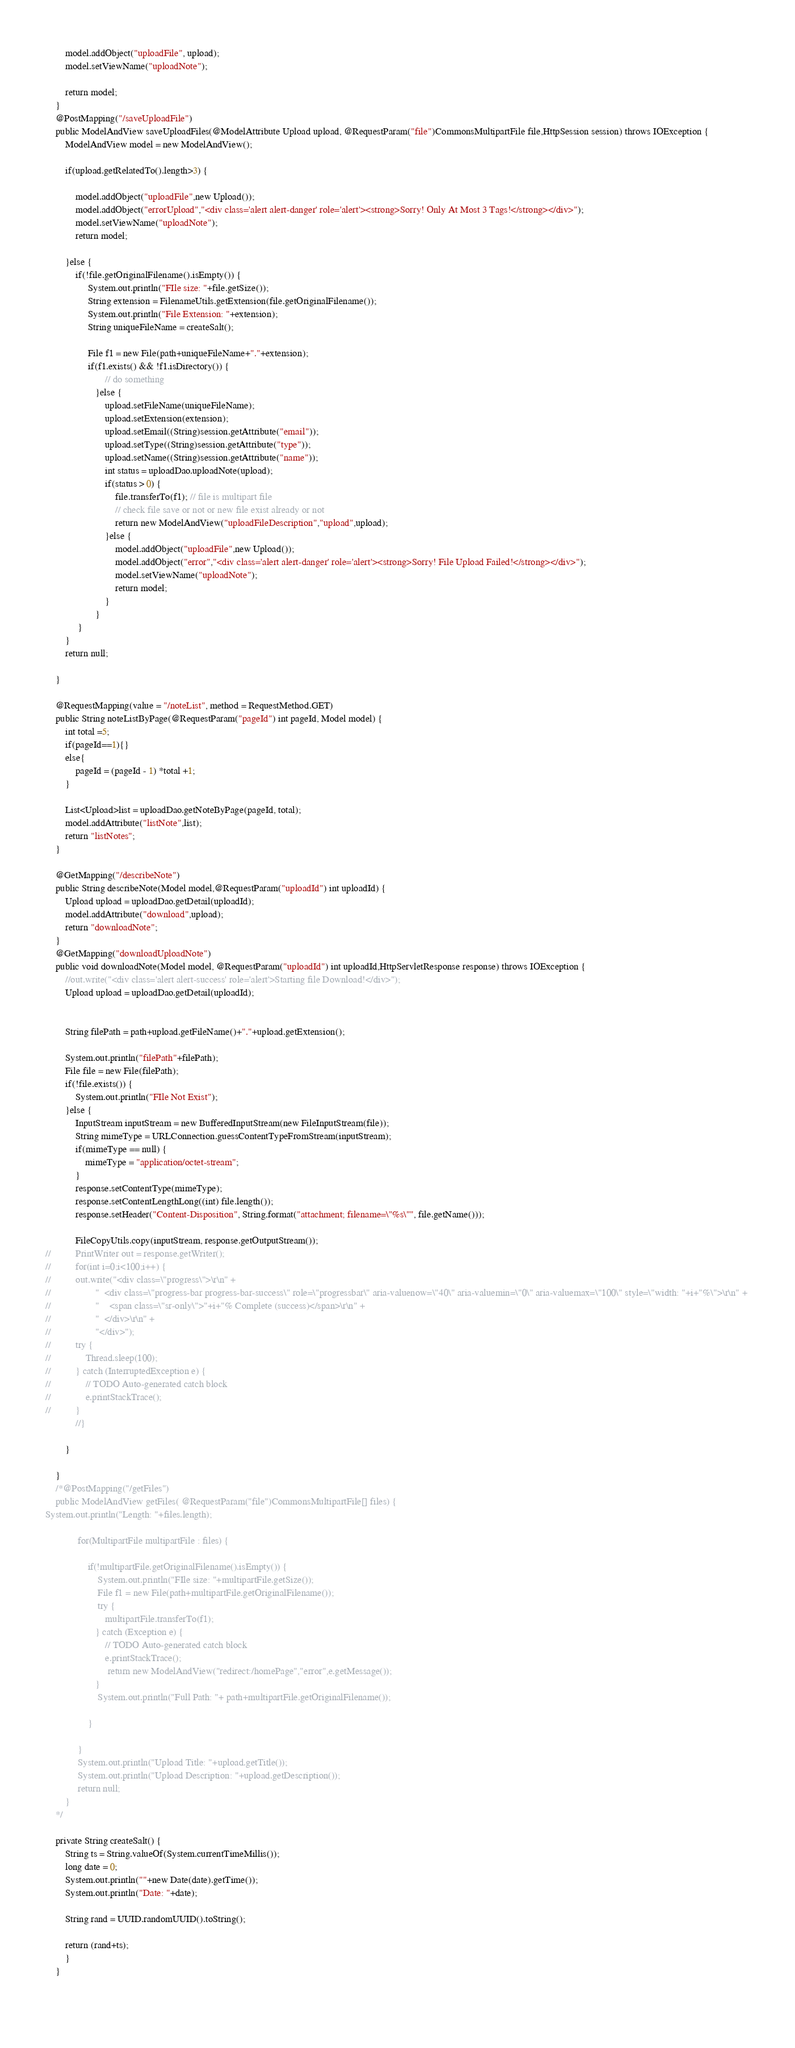<code> <loc_0><loc_0><loc_500><loc_500><_Java_>		model.addObject("uploadFile", upload);
		model.setViewName("uploadNote");
		
		return model;
	}
	@PostMapping("/saveUploadFile")
	public ModelAndView saveUploadFiles(@ModelAttribute Upload upload, @RequestParam("file")CommonsMultipartFile file,HttpSession session) throws IOException {
		ModelAndView model = new ModelAndView();
			
		if(upload.getRelatedTo().length>3) {
			
			model.addObject("uploadFile",new Upload());
			model.addObject("errorUpload","<div class='alert alert-danger' role='alert'><strong>Sorry! Only At Most 3 Tags!</strong></div>");
			model.setViewName("uploadNote");
			return model;

		}else {
			if(!file.getOriginalFilename().isEmpty()) {
				 System.out.println("FIle size: "+file.getSize());
				 String extension = FilenameUtils.getExtension(file.getOriginalFilename());
				 System.out.println("File Extension: "+extension);
				 String uniqueFileName = createSalt();
				
				 File f1 = new File(path+uniqueFileName+"."+extension);
				 if(f1.exists() && !f1.isDirectory()) { 
					    // do something
					}else {
						upload.setFileName(uniqueFileName);
						upload.setExtension(extension);
						upload.setEmail((String)session.getAttribute("email"));
						upload.setType((String)session.getAttribute("type"));
						upload.setName((String)session.getAttribute("name"));
						int status = uploadDao.uploadNote(upload);
						if(status > 0) {
							file.transferTo(f1); // file is multipart file	
							// check file save or not or new file exist already or not
							return new ModelAndView("uploadFileDescription","upload",upload);
						}else {
							model.addObject("uploadFile",new Upload());
							model.addObject("error","<div class='alert alert-danger' role='alert'><strong>Sorry! File Upload Failed!</strong></div>");
							model.setViewName("uploadNote");
							return model;
						}
					}  
			 }
		}
		return null; 
		
	}
	
	@RequestMapping(value = "/noteList", method = RequestMethod.GET)
	public String noteListByPage(@RequestParam("pageId") int pageId, Model model) {
		int total =5;
		if(pageId==1){}
		else{
			pageId = (pageId - 1) *total +1;
		}
		
		List<Upload>list = uploadDao.getNoteByPage(pageId, total);
		model.addAttribute("listNote",list);
		return "listNotes";
	}
	
	@GetMapping("/describeNote")
	public String describeNote(Model model,@RequestParam("uploadId") int uploadId) {
		Upload upload = uploadDao.getDetail(uploadId);
		model.addAttribute("download",upload);
		return "downloadNote";
	}
	@GetMapping("downloadUploadNote")
	public void downloadNote(Model model, @RequestParam("uploadId") int uploadId,HttpServletResponse response) throws IOException {
		//out.write("<div class='alert alert-success' role='alert'>Starting file Download!</div>");
		Upload upload = uploadDao.getDetail(uploadId);
		
		
		String filePath = path+upload.getFileName()+"."+upload.getExtension();
		
		System.out.println("filePath"+filePath);
		File file = new File(filePath);
		if(!file.exists()) {
			System.out.println("FIle Not Exist");
		}else {
			InputStream inputStream = new BufferedInputStream(new FileInputStream(file));
			String mimeType = URLConnection.guessContentTypeFromStream(inputStream);
			if(mimeType == null) {
				mimeType = "application/octet-stream";
			}
			response.setContentType(mimeType);
			response.setContentLengthLong((int) file.length());
			response.setHeader("Content-Disposition", String.format("attachment; filename=\"%s\"", file.getName()));
			
			FileCopyUtils.copy(inputStream, response.getOutputStream());
//			PrintWriter out = response.getWriter();
//			for(int i=0;i<100;i++) {
//			out.write("<div class=\"progress\">\r\n" + 
//					"  <div class=\"progress-bar progress-bar-success\" role=\"progressbar\" aria-valuenow=\"40\" aria-valuemin=\"0\" aria-valuemax=\"100\" style=\"width: "+i+"%\">\r\n" + 
//					"    <span class=\"sr-only\">"+i+"% Complete (success)</span>\r\n" + 
//					"  </div>\r\n" + 
//					"</div>");
//			try {
//				Thread.sleep(100);
//			} catch (InterruptedException e) {
//				// TODO Auto-generated catch block
//				e.printStackTrace();
//			}
			//}
			
		}
		
	}
	/*@PostMapping("/getFiles")
	public ModelAndView getFiles( @RequestParam("file")CommonsMultipartFile[] files) {
System.out.println("Length: "+files.length);
		
			 for(MultipartFile multipartFile : files) {
					
				 if(!multipartFile.getOriginalFilename().isEmpty()) {
					 System.out.println("FIle size: "+multipartFile.getSize());
					 File f1 = new File(path+multipartFile.getOriginalFilename());
					 try {
						multipartFile.transferTo(f1);
					} catch (Exception e) {
						// TODO Auto-generated catch block
						e.printStackTrace();
						 return new ModelAndView("redirect:/homePage","error",e.getMessage());
					}
					 System.out.println("Full Path: "+ path+multipartFile.getOriginalFilename());
					 
				 }
				
			 }
			 System.out.println("Upload Title: "+upload.getTitle());
			 System.out.println("Upload Description: "+upload.getDescription());
			 return null;
		}
	*/
	
	private String createSalt() {
	    String ts = String.valueOf(System.currentTimeMillis());
	    long date = 0;
	    System.out.println(""+new Date(date).getTime());
	    System.out.println("Date: "+date);
	   
	    String rand = UUID.randomUUID().toString();
	    
	    return (rand+ts);
		}
	}

	


</code> 